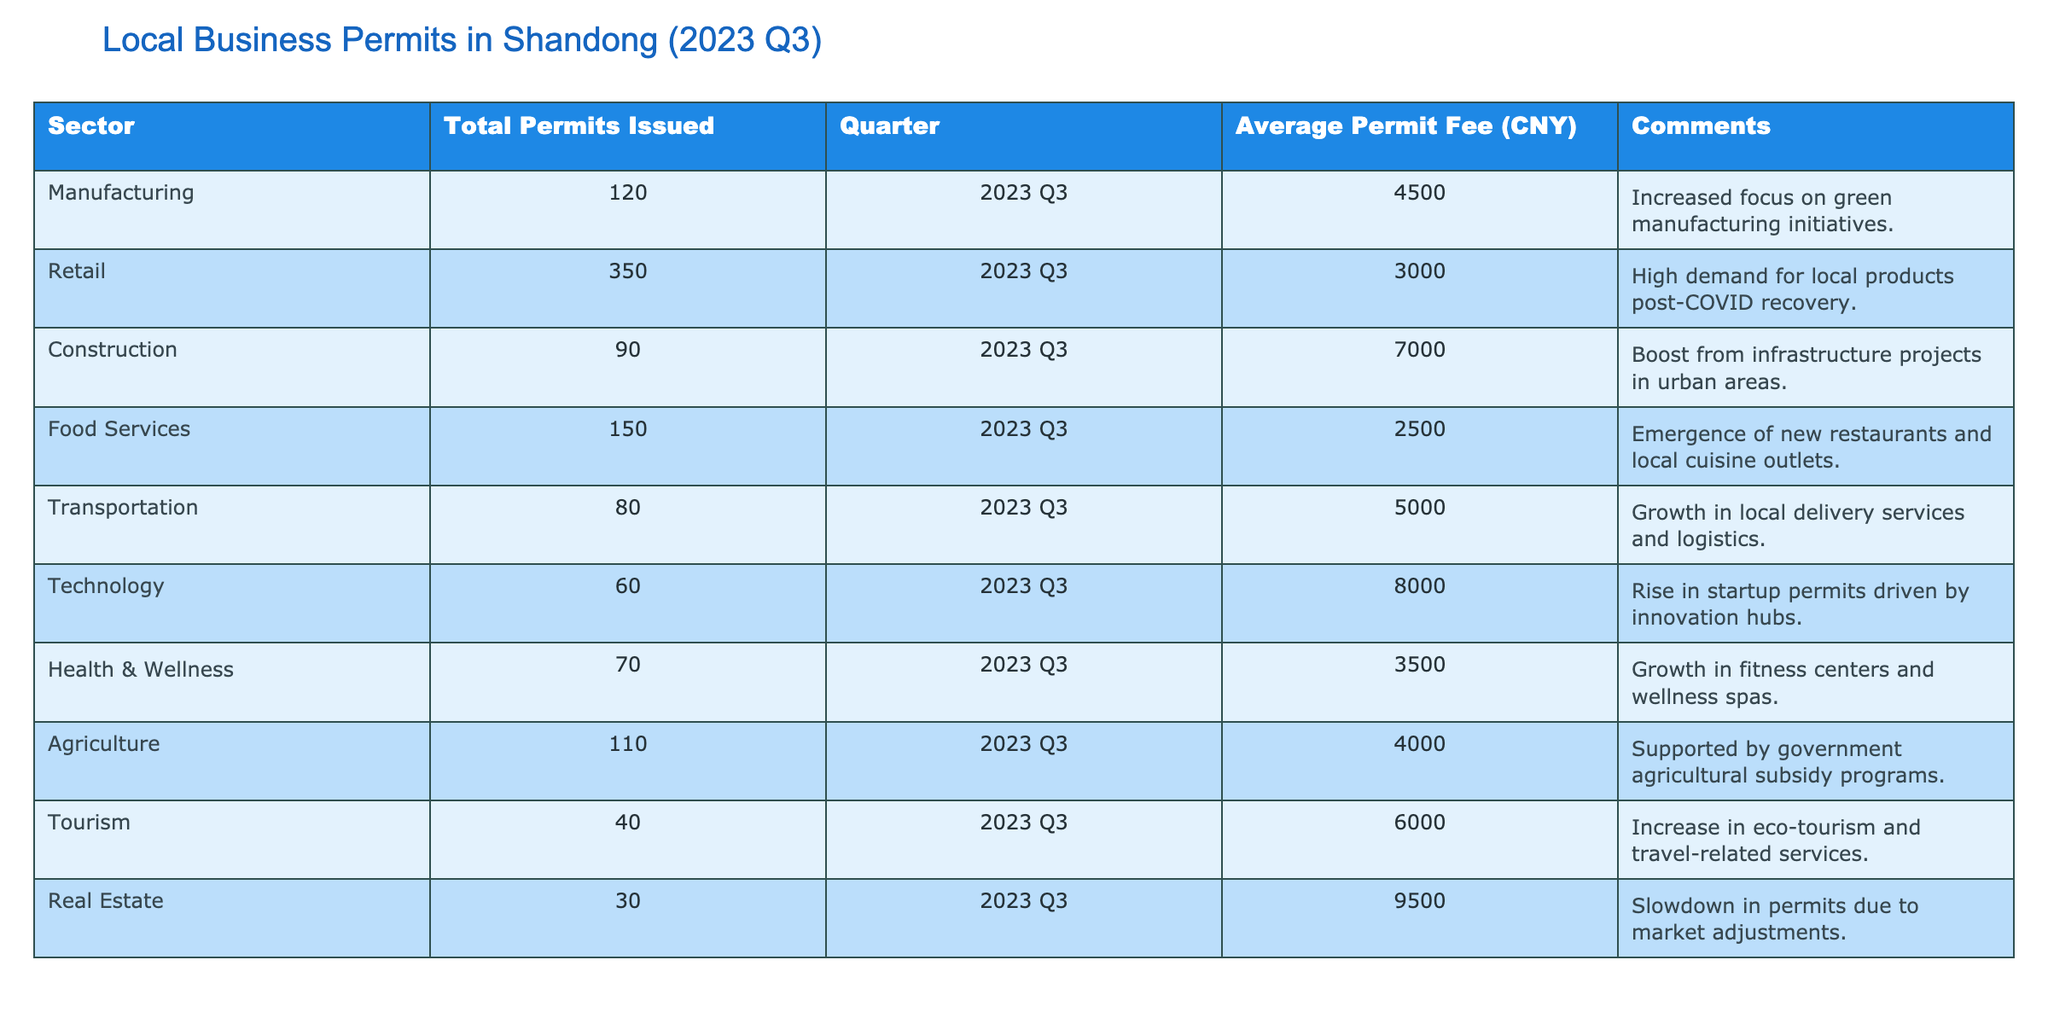What sector had the highest number of permits issued? The table shows that the Retail sector had the highest number of permits issued, with a total of 350. This can be seen directly in the "Total Permits Issued" column.
Answer: Retail What is the average permit fee for the Construction sector? According to the table, the average permit fee for the Construction sector is 7000 CNY, which is noted in the corresponding column for that sector.
Answer: 7000 CNY Which sector had the lowest average permit fee, and what was that fee? The table indicates that the Food Services sector had the lowest average permit fee at 2500 CNY. This can be found in the "Average Permit Fee (CNY)" column by comparing values across all sectors.
Answer: 2500 CNY How many total permits were issued in the Manufacturing and Agriculture sectors combined? To find this, we add the total permits issued in the Manufacturing sector (120) and the Agriculture sector (110). The total is 120 + 110 = 230.
Answer: 230 Is it true that the Technology sector issued more permits than the Transportation sector? Looking at the table, the Technology sector issued 60 permits, while the Transportation sector issued 80 permits. Therefore, the statement is false.
Answer: No What is the difference in average permit fees between the Real Estate and Tourism sectors? The average permit fee for the Real Estate sector is 9500 CNY and for the Tourism sector, it is 6000 CNY. The difference is calculated as 9500 - 6000 = 3500 CNY.
Answer: 3500 CNY Which sector had a notable increase due to government support, and what was it related to? The Agriculture sector had a noted increase in permits issued, which was supported by government agricultural subsidy programs, as stated in the comments for that sector.
Answer: Agriculture What percentage of total permits issued belong to the Food Services sector? First, we calculate the total number of permits issued across all sectors: 120 + 350 + 90 + 150 + 80 + 60 + 70 + 110 + 40 + 30 = 1110. Then, for the Food Services sector: (150/1110) * 100 = 13.51%.
Answer: 13.51% How many more permits were issued in the Retail sector compared to the Health & Wellness sector? The Retail sector issued 350 permits, while the Health & Wellness sector issued 70 permits. The difference is 350 - 70 = 280 permits.
Answer: 280 permits 